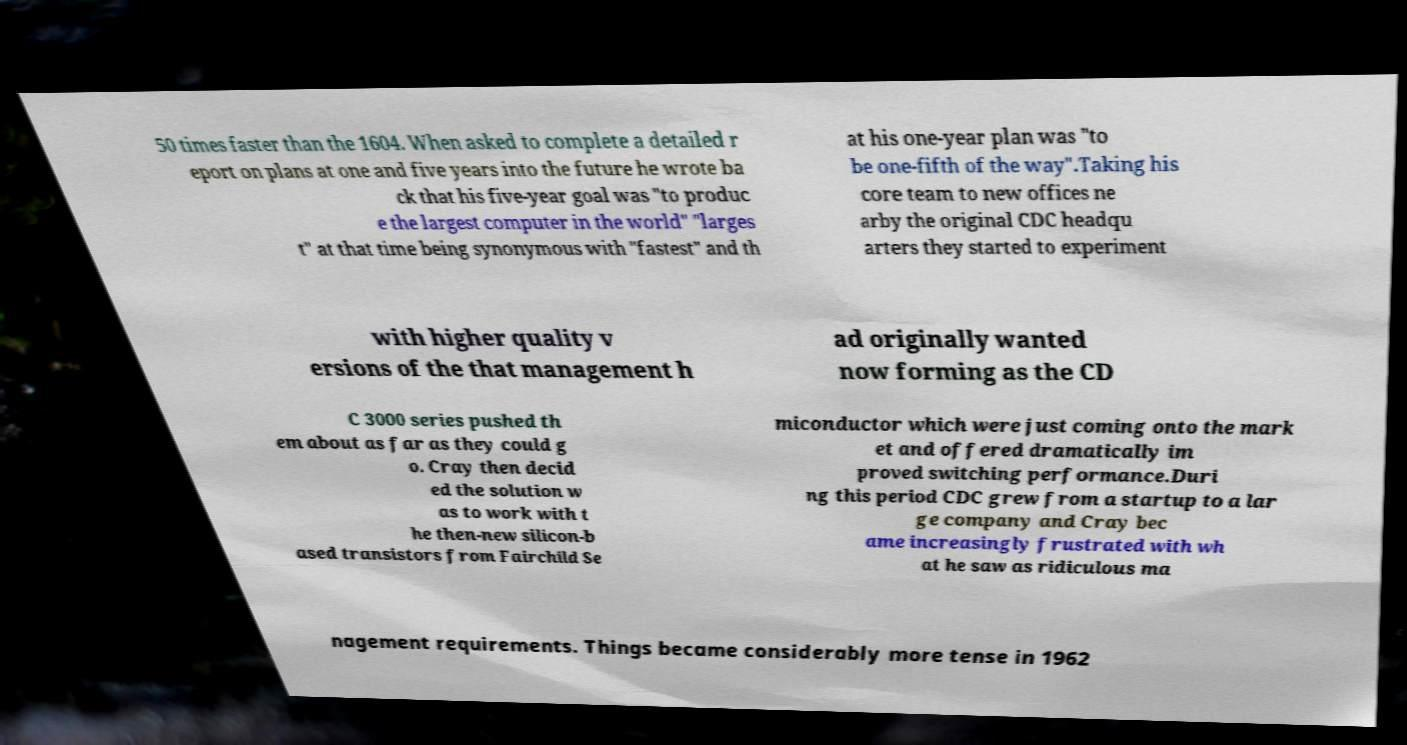Could you assist in decoding the text presented in this image and type it out clearly? 50 times faster than the 1604. When asked to complete a detailed r eport on plans at one and five years into the future he wrote ba ck that his five-year goal was "to produc e the largest computer in the world" "larges t" at that time being synonymous with "fastest" and th at his one-year plan was "to be one-fifth of the way".Taking his core team to new offices ne arby the original CDC headqu arters they started to experiment with higher quality v ersions of the that management h ad originally wanted now forming as the CD C 3000 series pushed th em about as far as they could g o. Cray then decid ed the solution w as to work with t he then-new silicon-b ased transistors from Fairchild Se miconductor which were just coming onto the mark et and offered dramatically im proved switching performance.Duri ng this period CDC grew from a startup to a lar ge company and Cray bec ame increasingly frustrated with wh at he saw as ridiculous ma nagement requirements. Things became considerably more tense in 1962 